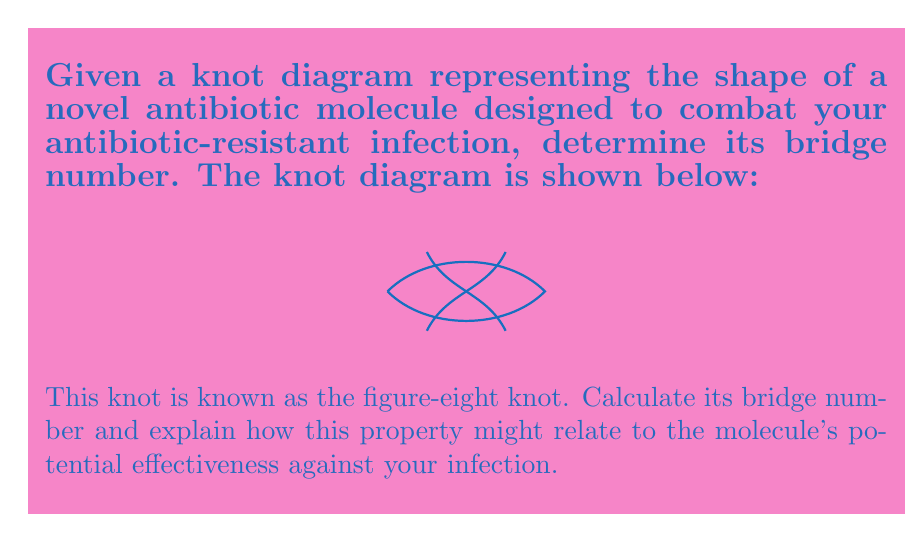What is the answer to this math problem? To compute the bridge number of the given knot, we'll follow these steps:

1) The bridge number of a knot is defined as the minimum number of bridges needed in any bridge presentation of the knot.

2) A bridge in a knot projection is an arc that goes over at least one crossing before returning to the undersides.

3) For the figure-eight knot:
   
   a) We can see that the knot can be arranged to have two "maxima" or overarches.
   
   b) Each of these overarches constitutes a bridge.

4) It's impossible to represent the figure-eight knot with fewer than two bridges because:
   
   a) The figure-eight knot is non-trivial (not isotopic to the unknot).
   
   b) Any knot with a bridge number of 1 would be trivial.

5) Therefore, the bridge number of the figure-eight knot is 2.

Relating to the antibiotic molecule:

6) The bridge number can be interpreted as a measure of the molecule's complexity.

7) A higher bridge number might indicate:
   
   a) More potential binding sites for the antibiotic.
   
   b) A more complex structure that might be harder for bacteria to develop resistance against.

8) However, a bridge number of 2 suggests a relatively simple structure, which could mean:
   
   a) The molecule might be easier for your body to process and distribute.
   
   b) It might have fewer side effects due to its simpler structure.

9) The effectiveness against your infection would depend on many other factors beyond just the bridge number, such as the specific binding mechanisms and the nature of the antibiotic resistance.
Answer: 2 